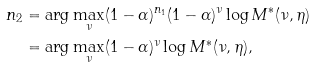<formula> <loc_0><loc_0><loc_500><loc_500>n _ { 2 } & = \arg \max _ { \nu } ( 1 - \alpha ) ^ { n _ { 1 } } ( 1 - \alpha ) ^ { \nu } \log M ^ { * } ( \nu , \eta ) \\ & = \arg \max _ { \nu } ( 1 - \alpha ) ^ { \nu } \log M ^ { * } ( \nu , \eta ) ,</formula> 